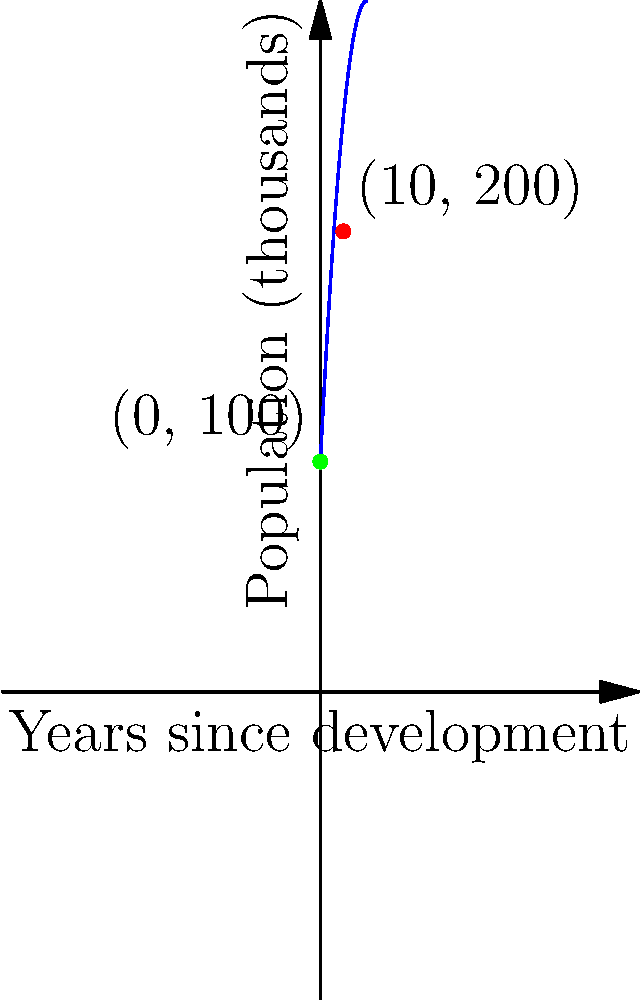A newly developed industrial area's population growth can be modeled by the quadratic function $P(t) = 100 + 20t - 0.5t^2$, where $P$ is the population in thousands and $t$ is the number of years since development. Based on this model, in how many years will the area reach its peak population, and what will that population be? To solve this problem, we need to follow these steps:

1) The peak of a quadratic function occurs at the vertex of the parabola. For a quadratic function in the form $f(x) = ax^2 + bx + c$, the x-coordinate of the vertex is given by $x = -\frac{b}{2a}$.

2) In our function $P(t) = 100 + 20t - 0.5t^2$, we have:
   $a = -0.5$
   $b = 20$
   $c = 100$

3) Plugging these values into the formula:
   $t = -\frac{20}{2(-0.5)} = -\frac{20}{-1} = 20$

4) This means the population will peak 20 years after development.

5) To find the peak population, we substitute $t = 20$ into our original function:
   $P(20) = 100 + 20(20) - 0.5(20)^2$
   $= 100 + 400 - 0.5(400)$
   $= 500 - 200 = 300$

Therefore, the population will peak at 300,000 people after 20 years.
Answer: 20 years; 300,000 people 